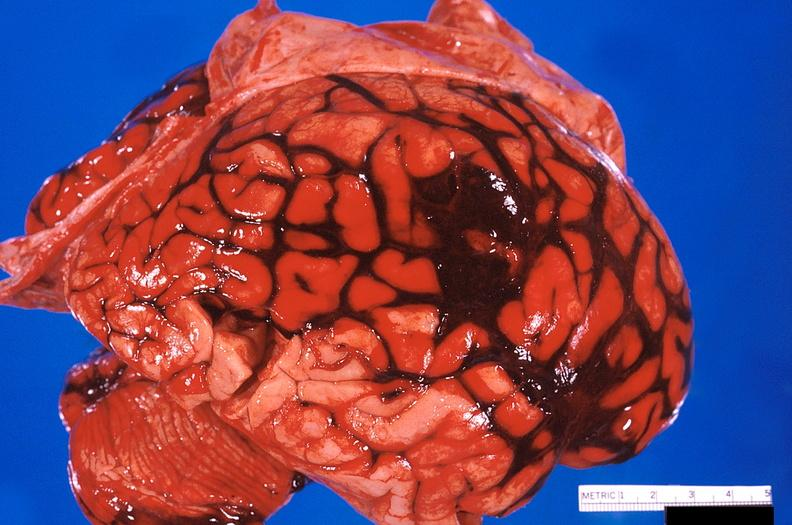does side show brain, subarachanoid hemorrhage due to ruptured aneurysm?
Answer the question using a single word or phrase. No 